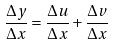<formula> <loc_0><loc_0><loc_500><loc_500>\frac { \Delta y } { \Delta x } = \frac { \Delta u } { \Delta x } + \frac { \Delta v } { \Delta x }</formula> 